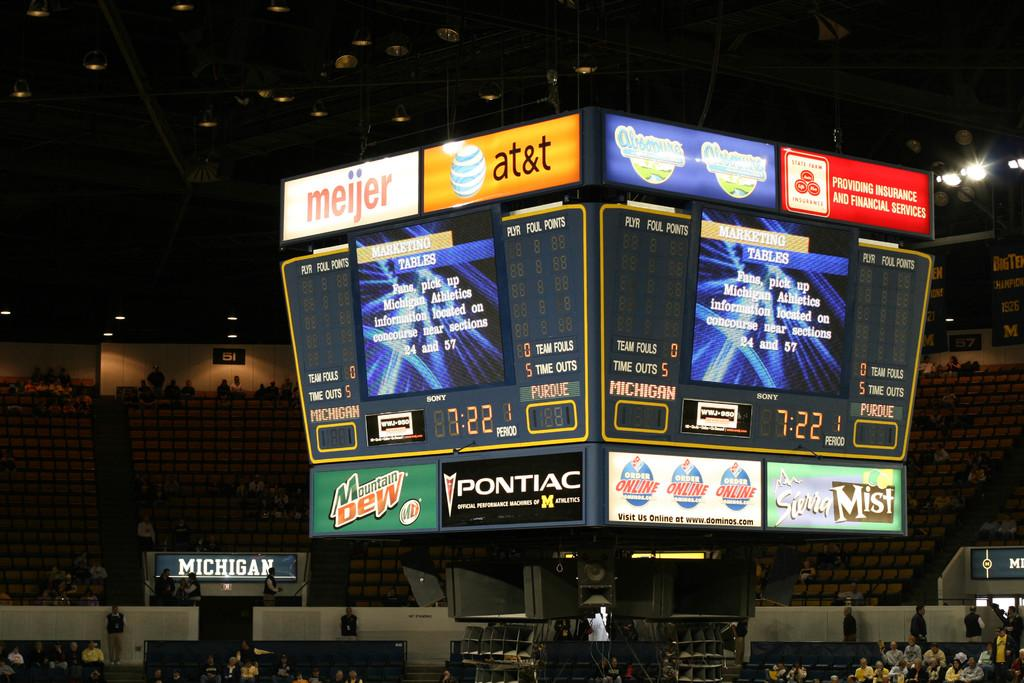What is located in the middle of the image? There are two screens in the middle of the image. What can be seen at the bottom of the image? There are people sitting at the bottom of the image. What type of animals can be seen blowing up balloons at the zoo in the image? There is no zoo or animals present in the image; it features two screens and people sitting at the bottom. 